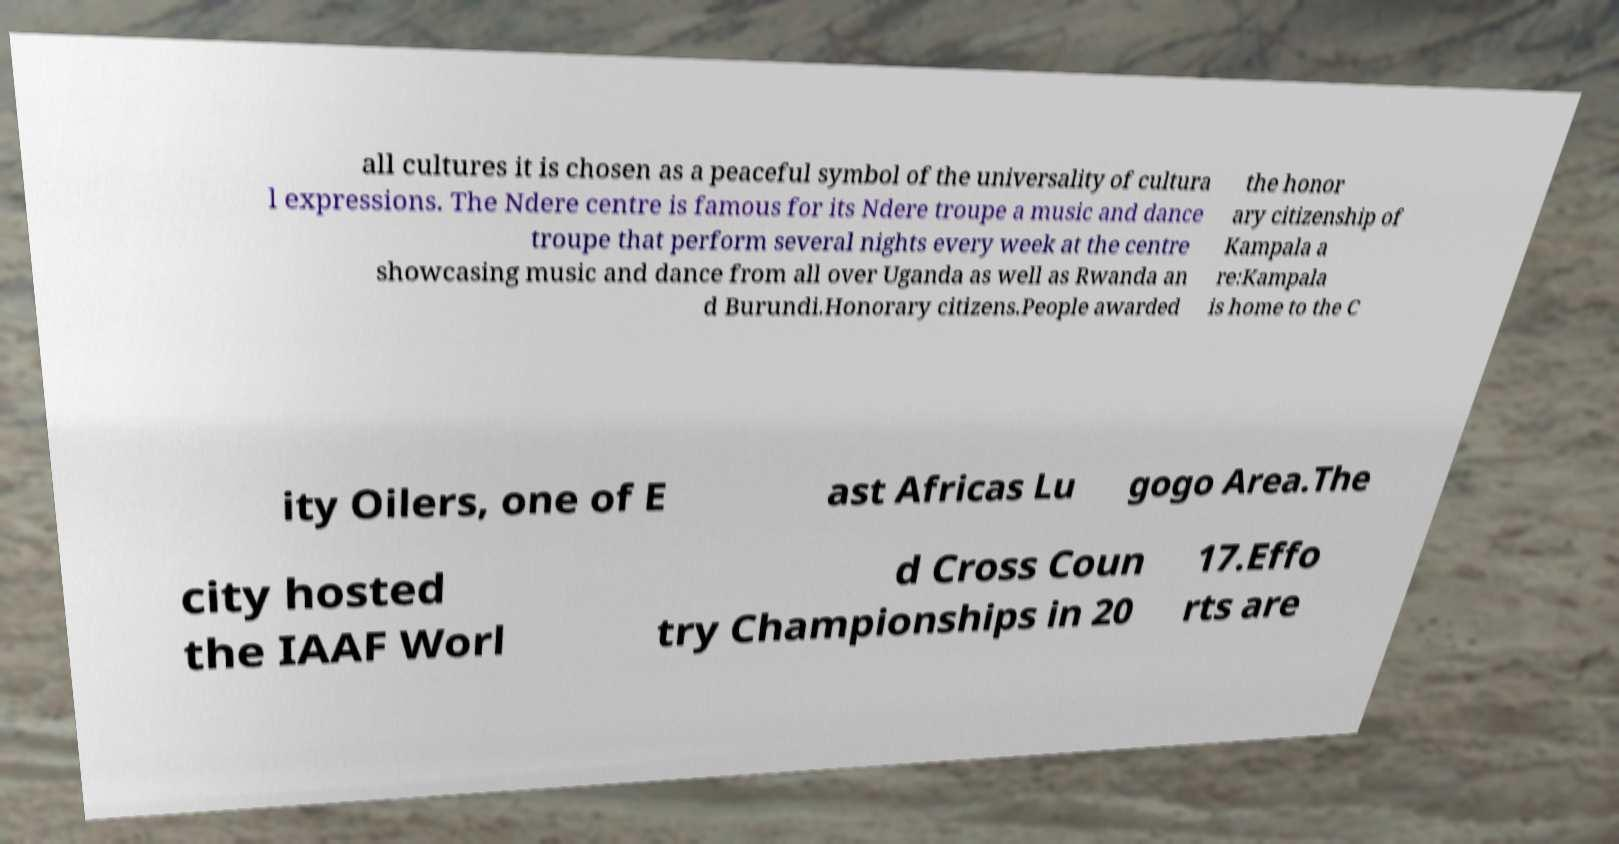Please read and relay the text visible in this image. What does it say? all cultures it is chosen as a peaceful symbol of the universality of cultura l expressions. The Ndere centre is famous for its Ndere troupe a music and dance troupe that perform several nights every week at the centre showcasing music and dance from all over Uganda as well as Rwanda an d Burundi.Honorary citizens.People awarded the honor ary citizenship of Kampala a re:Kampala is home to the C ity Oilers, one of E ast Africas Lu gogo Area.The city hosted the IAAF Worl d Cross Coun try Championships in 20 17.Effo rts are 